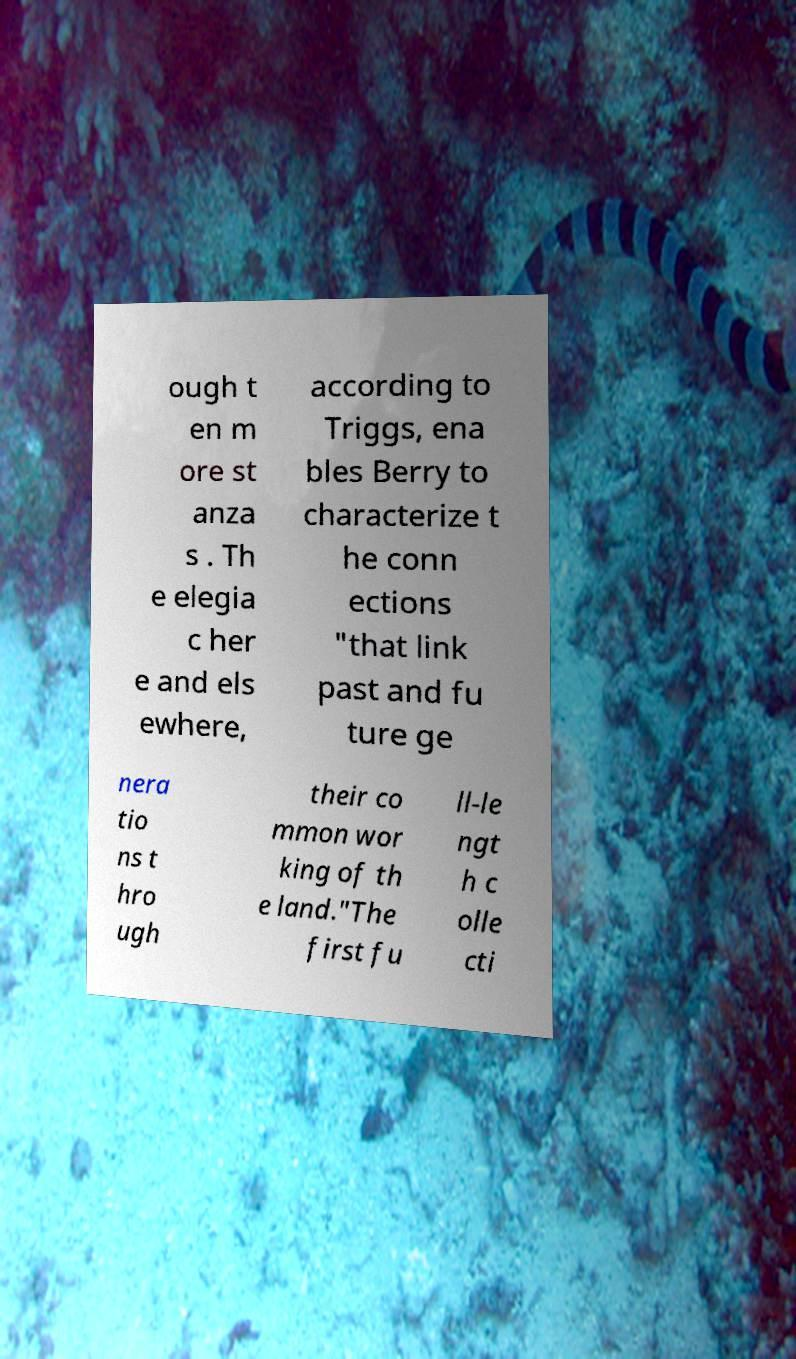What messages or text are displayed in this image? I need them in a readable, typed format. ough t en m ore st anza s . Th e elegia c her e and els ewhere, according to Triggs, ena bles Berry to characterize t he conn ections "that link past and fu ture ge nera tio ns t hro ugh their co mmon wor king of th e land."The first fu ll-le ngt h c olle cti 